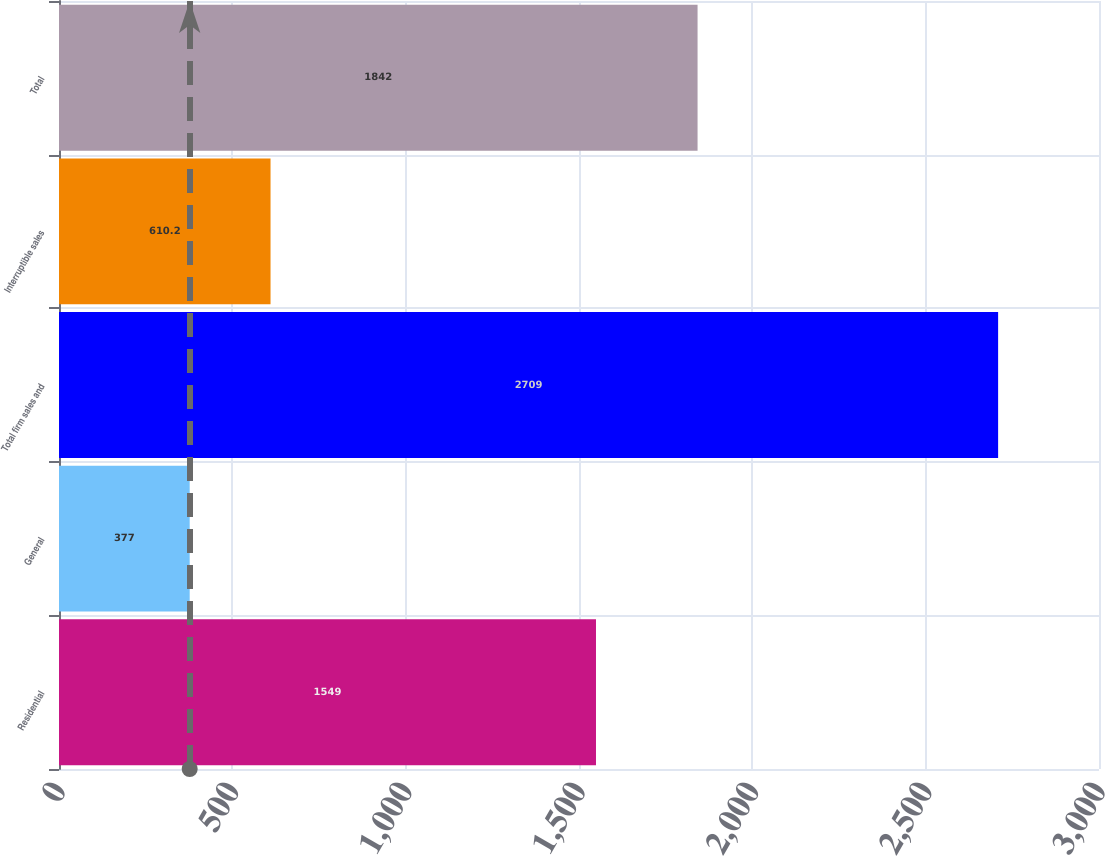<chart> <loc_0><loc_0><loc_500><loc_500><bar_chart><fcel>Residential<fcel>General<fcel>Total firm sales and<fcel>Interruptible sales<fcel>Total<nl><fcel>1549<fcel>377<fcel>2709<fcel>610.2<fcel>1842<nl></chart> 